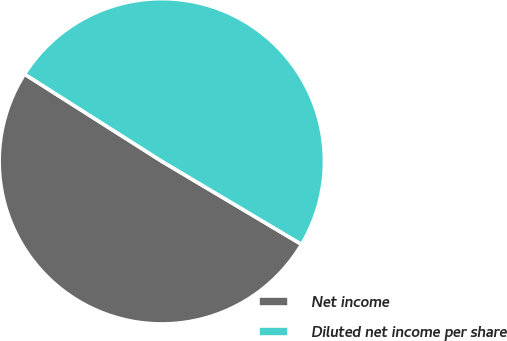<chart> <loc_0><loc_0><loc_500><loc_500><pie_chart><fcel>Net income<fcel>Diluted net income per share<nl><fcel>50.47%<fcel>49.53%<nl></chart> 